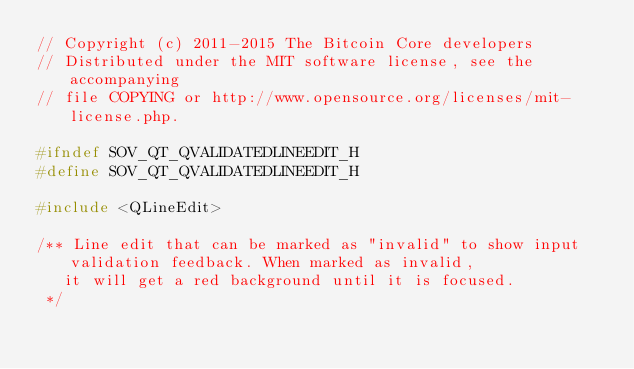<code> <loc_0><loc_0><loc_500><loc_500><_C_>// Copyright (c) 2011-2015 The Bitcoin Core developers
// Distributed under the MIT software license, see the accompanying
// file COPYING or http://www.opensource.org/licenses/mit-license.php.

#ifndef SOV_QT_QVALIDATEDLINEEDIT_H
#define SOV_QT_QVALIDATEDLINEEDIT_H

#include <QLineEdit>

/** Line edit that can be marked as "invalid" to show input validation feedback. When marked as invalid,
   it will get a red background until it is focused.
 */</code> 